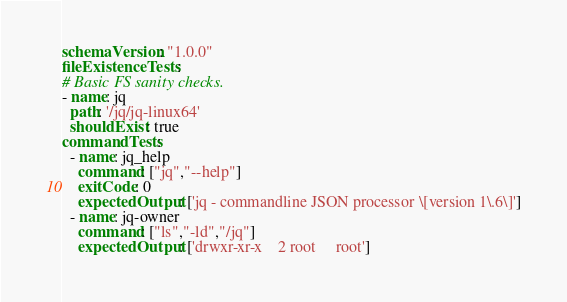Convert code to text. <code><loc_0><loc_0><loc_500><loc_500><_YAML_>schemaVersion: "1.0.0"
fileExistenceTests:
# Basic FS sanity checks.
- name: jq
  path: '/jq/jq-linux64'
  shouldExist: true
commandTests:
  - name: jq_help
    command: ["jq","--help"]
    exitCode: 0
    expectedOutput: ['jq - commandline JSON processor \[version 1\.6\]']
  - name: jq-owner
    command: ["ls","-ld","/jq"]
    expectedOutput: ['drwxr-xr-x    2 root     root']</code> 